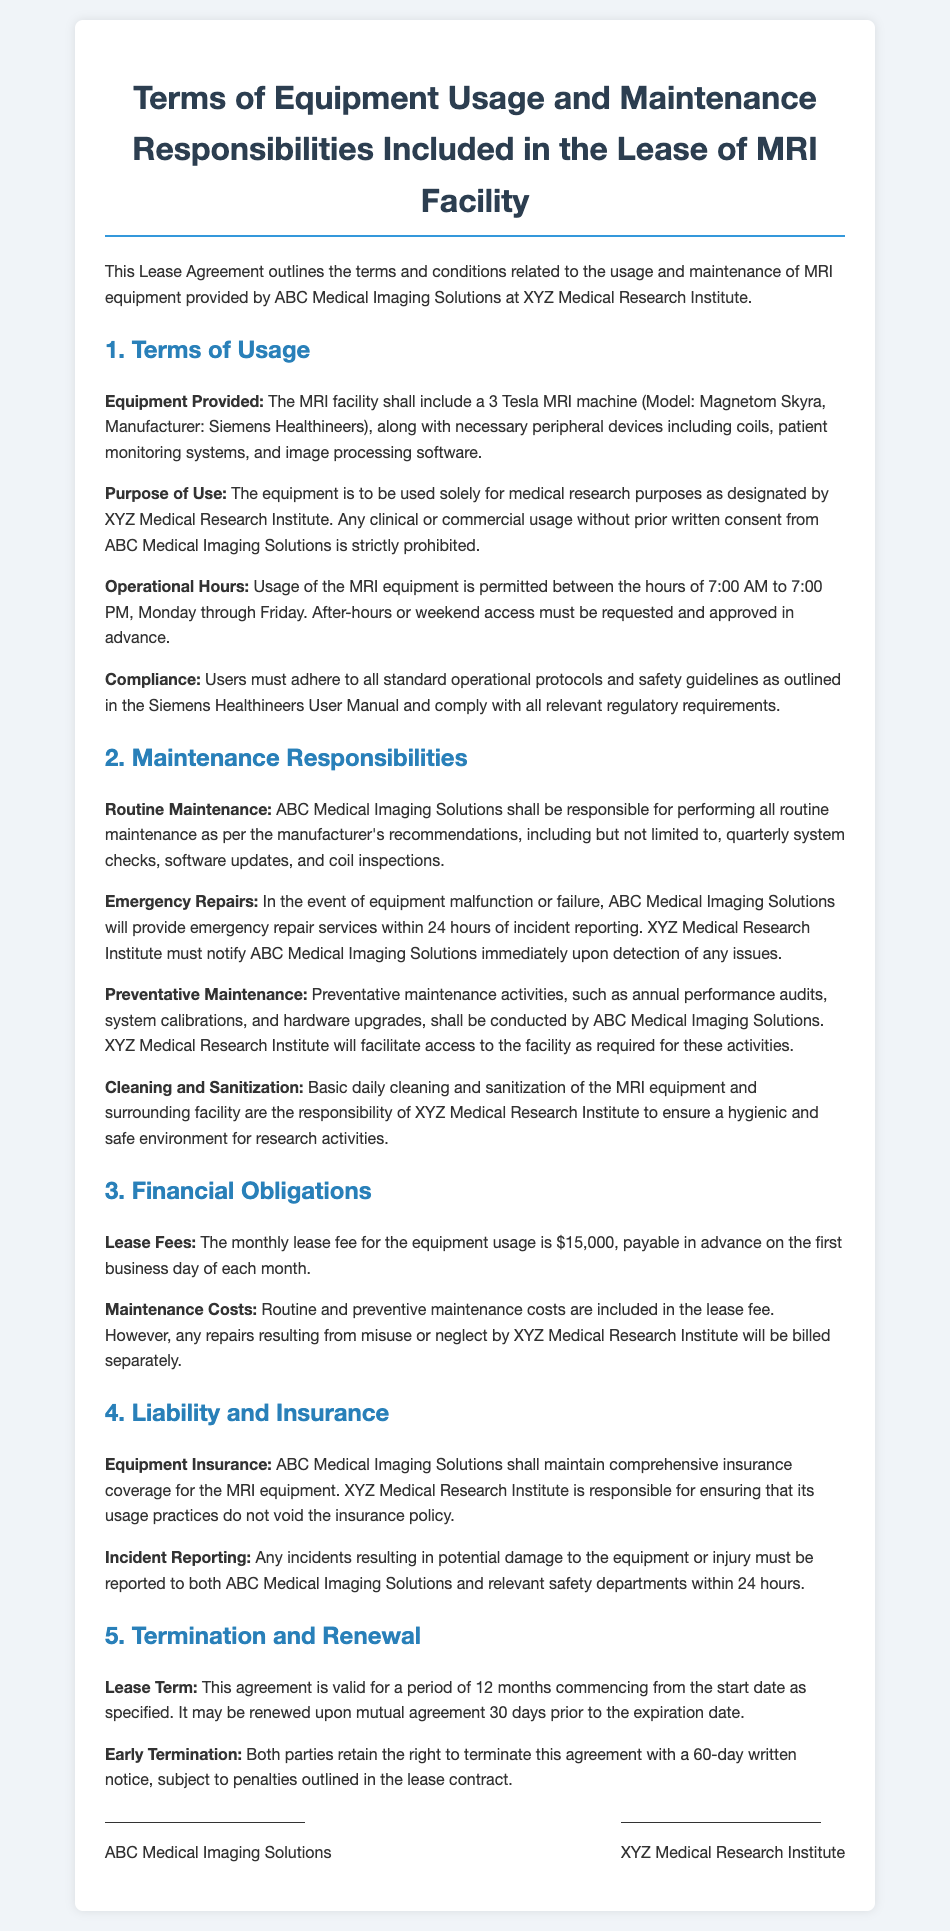What model of MRI machine is included? The document specifies the equipment to include a 3 Tesla MRI machine, Model Magnetom Skyra, from Siemens Healthineers.
Answer: Magnetom Skyra What are the operational hours for MRI usage? The operational hours outlined in the document are between 7:00 AM to 7:00 PM, Monday through Friday.
Answer: 7:00 AM to 7:00 PM, Monday through Friday Who is responsible for emergency repairs? According to the document, ABC Medical Imaging Solutions is responsible for providing emergency repair services within 24 hours of incident reporting.
Answer: ABC Medical Imaging Solutions What cleaning responsibility does XYZ Medical Research Institute have? The document states that basic daily cleaning and sanitization of the MRI equipment and surrounding facility are the responsibility of XYZ Medical Research Institute.
Answer: Basic daily cleaning and sanitization What is the monthly lease fee for the equipment? The document specifies the monthly lease fee for the equipment usage is $15,000.
Answer: $15,000 What must be done 30 days prior to lease expiration? The lease agreement requires that renewal must be discussed upon mutual agreement 30 days prior to the expiration date.
Answer: Mutual agreement What is the lease term duration? The document specifies that the lease term is valid for a period of 12 months.
Answer: 12 months What must be reported within 24 hours? Any incidents resulting in potential damage to the equipment or injury must be reported within 24 hours, as outlined in the document.
Answer: Incidents Who retains the right to terminate the agreement? Both parties retain the right to terminate the agreement with a 60-day written notice as mentioned in the document.
Answer: Both parties 